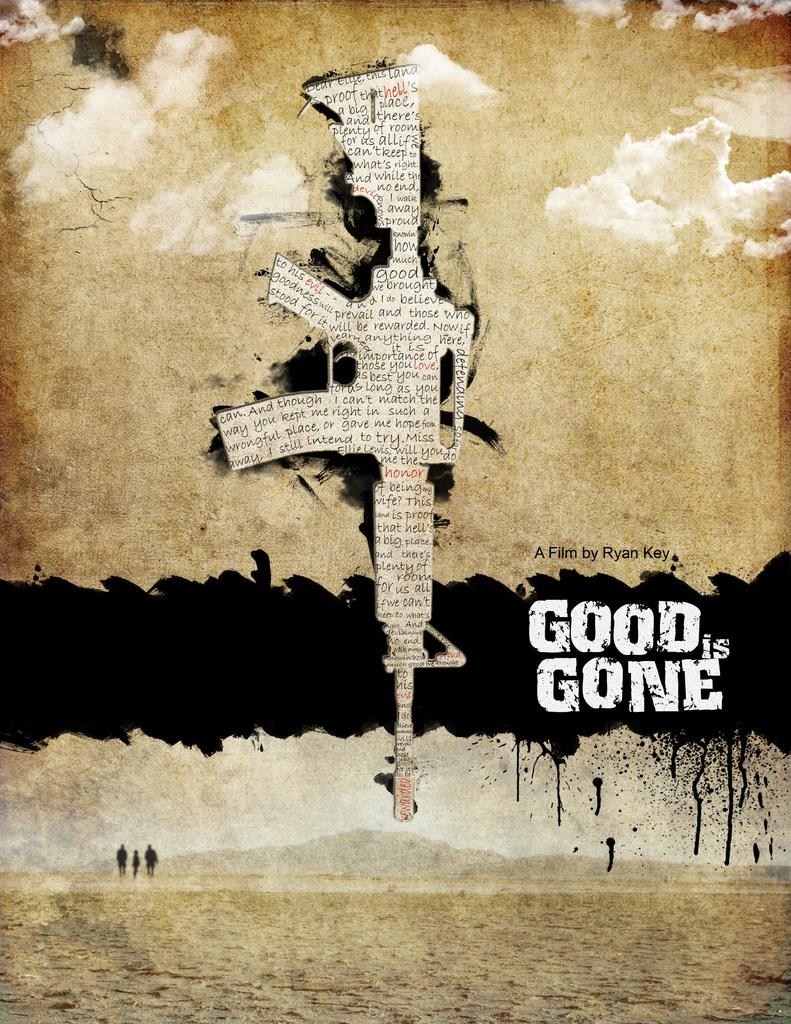What is the name of the book?
Your answer should be compact. Good is gone. Who is this film by?
Ensure brevity in your answer.  Ryan key. 